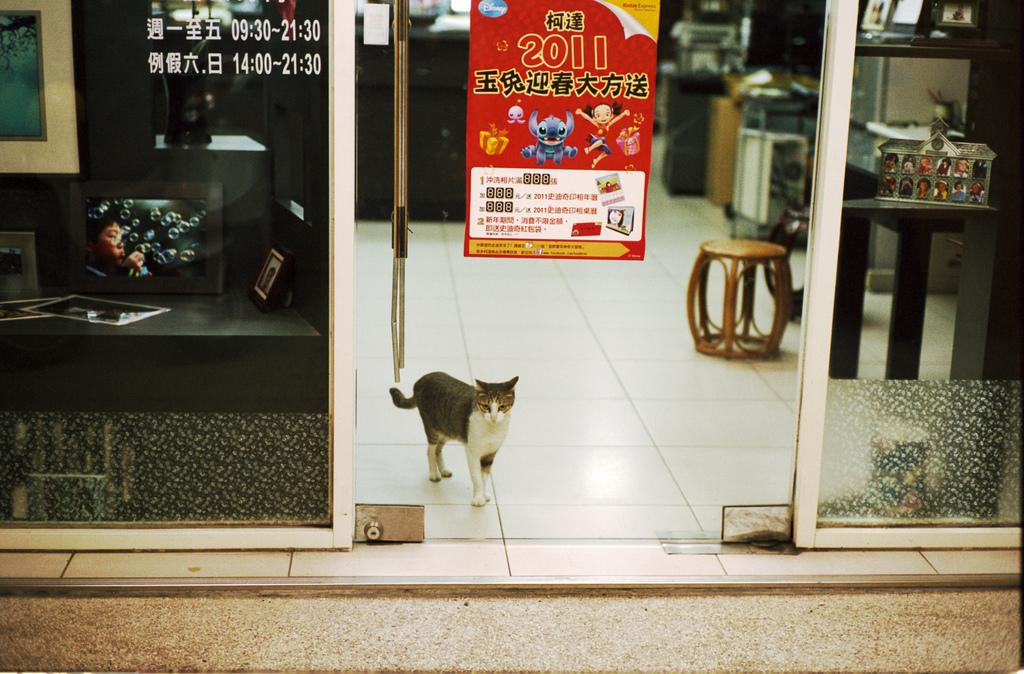What type of animal is in the image? There is a cat in the image. What is written on the door in the image? "2011" is written on the door in the image. What type of debt is being discussed in the image? There is no mention of debt in the image; it features a cat and a door with "2011" written on it. What color is the paint on the door in the image? The provided facts do not mention the color of the paint on the door, so it cannot be determined from the image. 